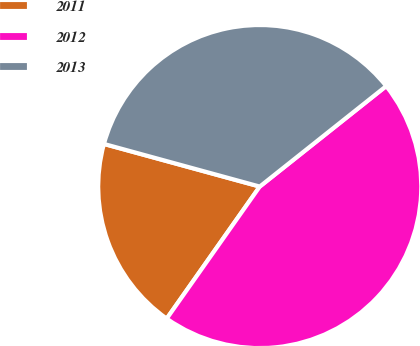Convert chart. <chart><loc_0><loc_0><loc_500><loc_500><pie_chart><fcel>2011<fcel>2012<fcel>2013<nl><fcel>19.48%<fcel>45.45%<fcel>35.06%<nl></chart> 